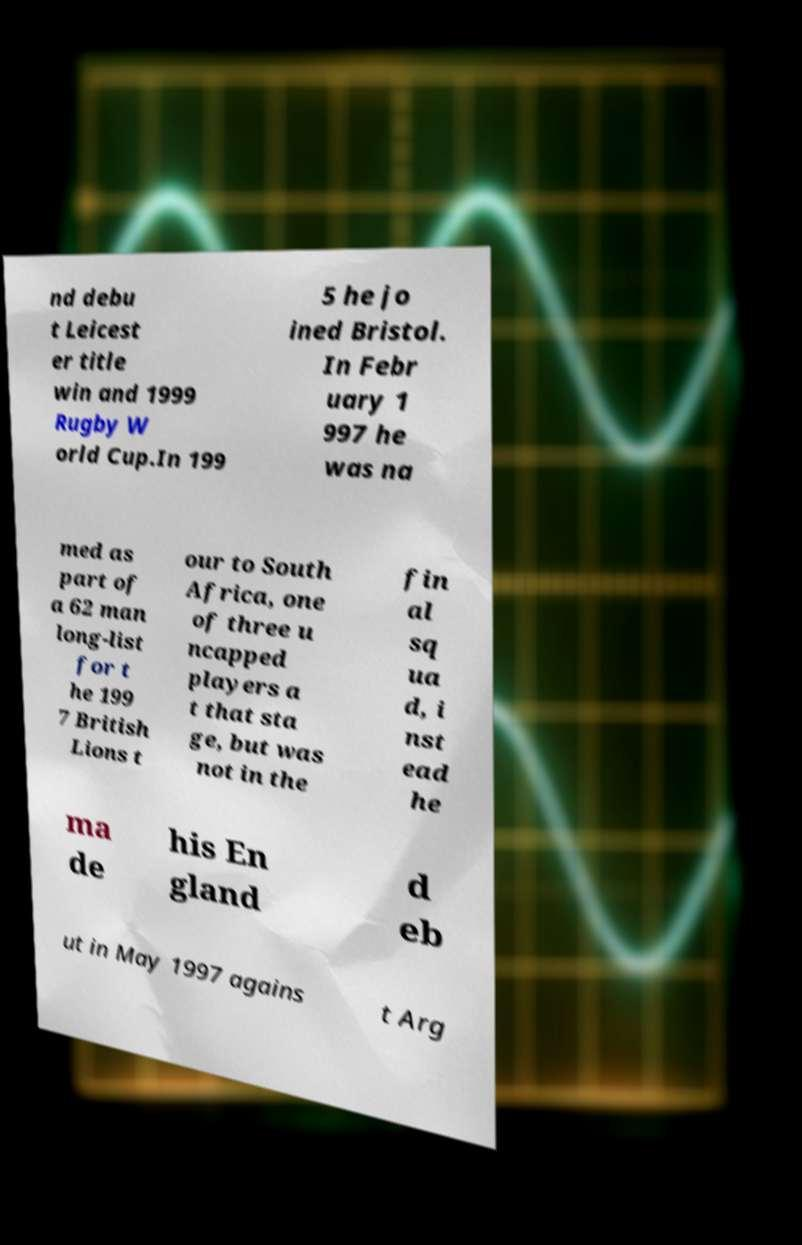Could you extract and type out the text from this image? nd debu t Leicest er title win and 1999 Rugby W orld Cup.In 199 5 he jo ined Bristol. In Febr uary 1 997 he was na med as part of a 62 man long-list for t he 199 7 British Lions t our to South Africa, one of three u ncapped players a t that sta ge, but was not in the fin al sq ua d, i nst ead he ma de his En gland d eb ut in May 1997 agains t Arg 